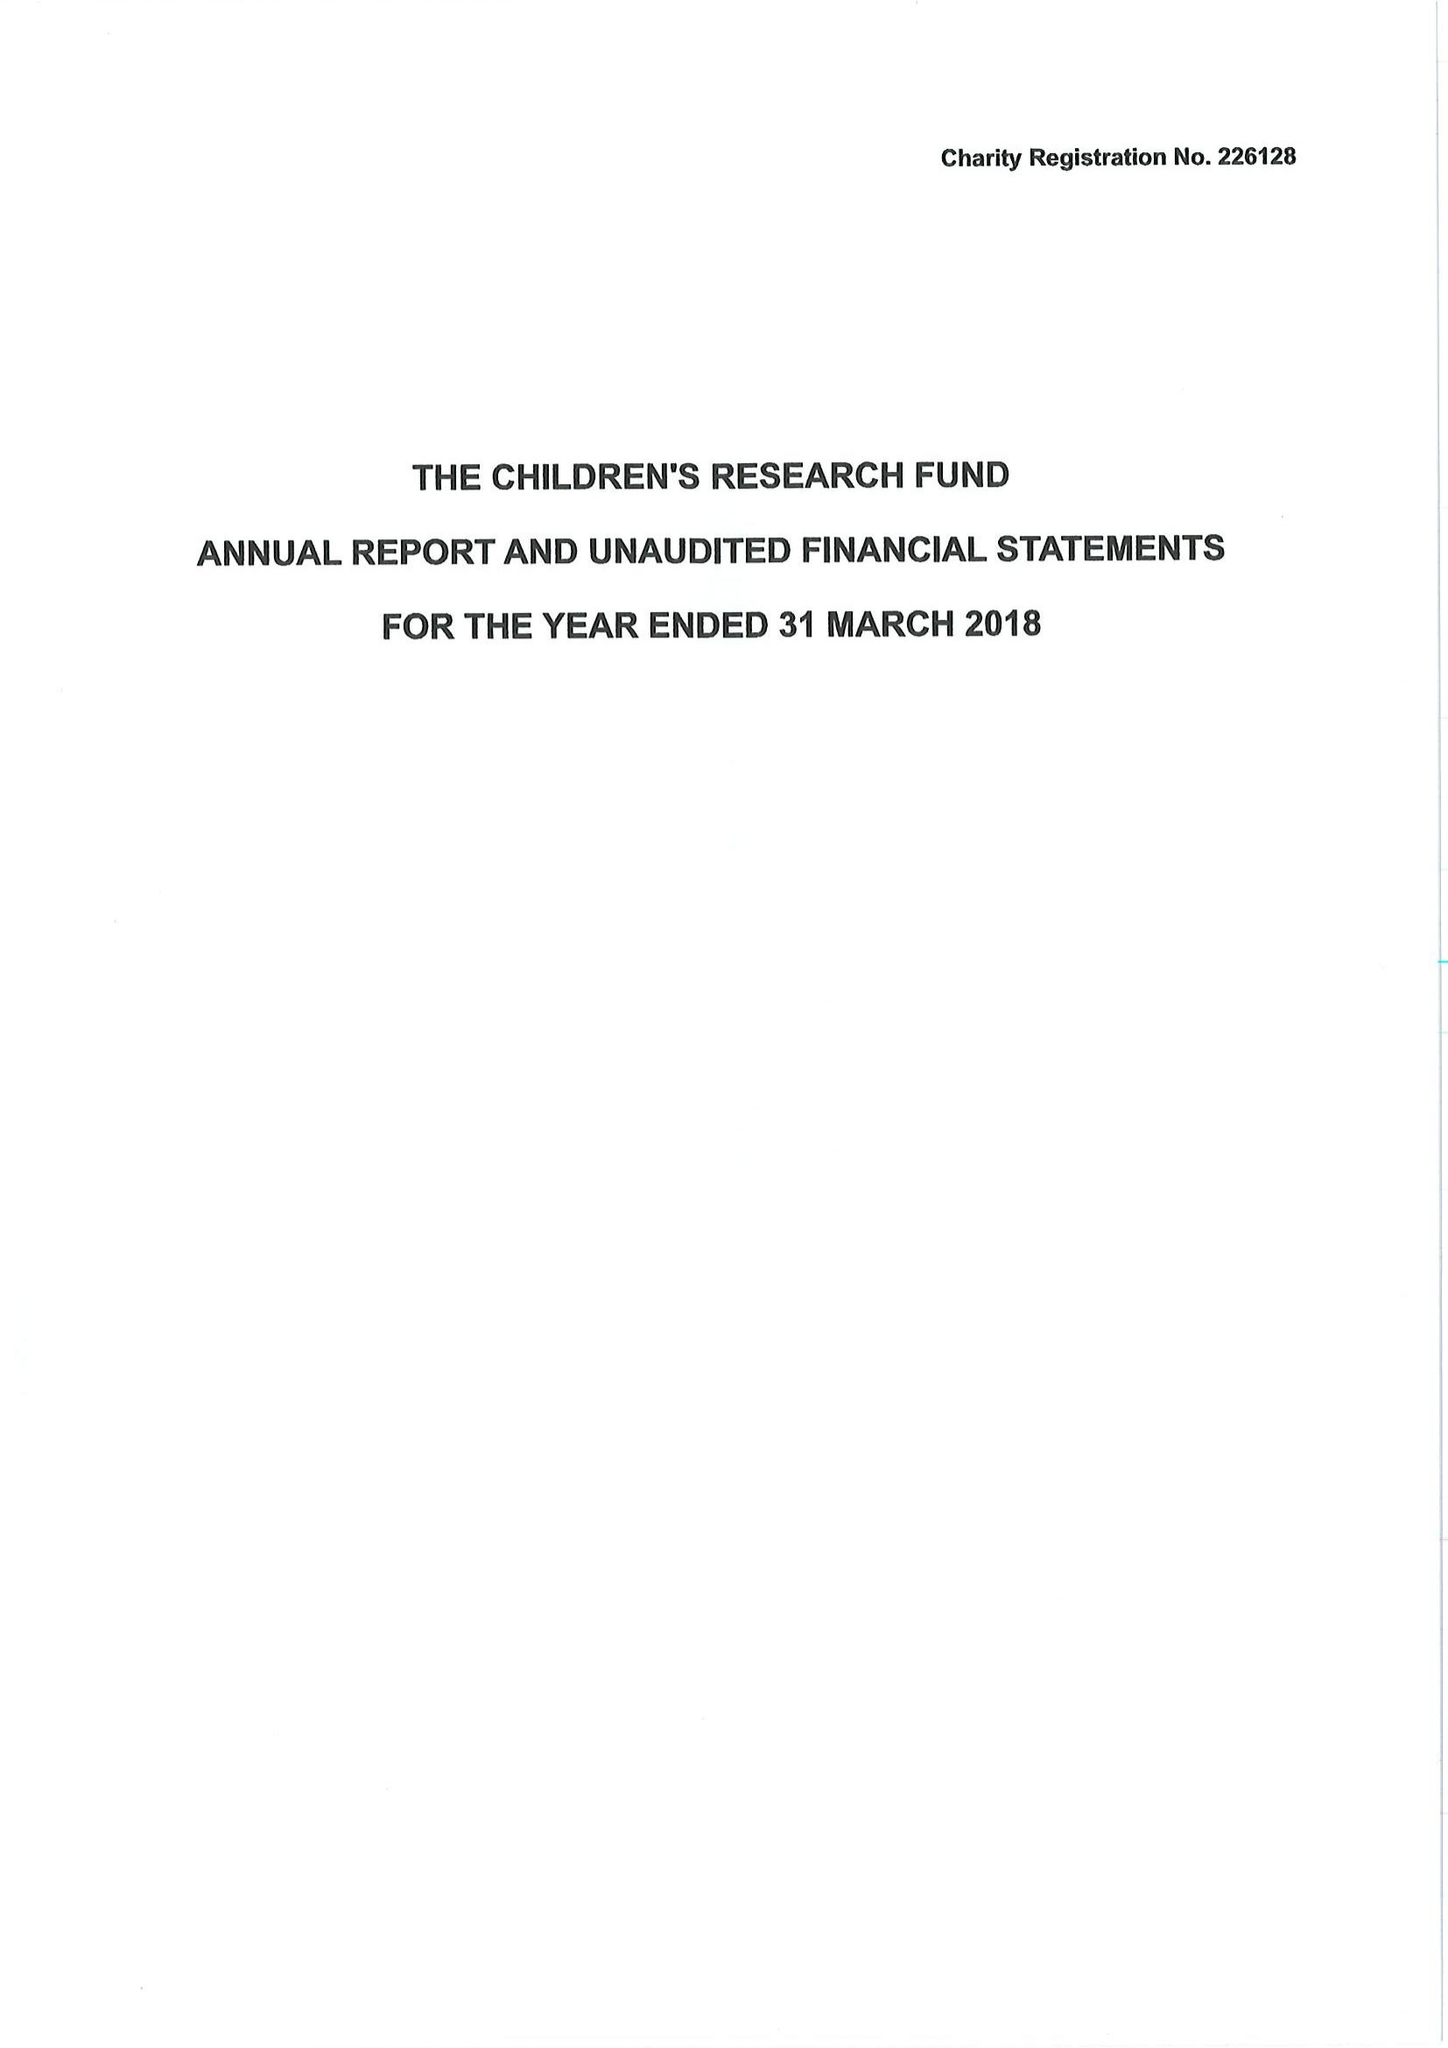What is the value for the spending_annually_in_british_pounds?
Answer the question using a single word or phrase. 861818.00 